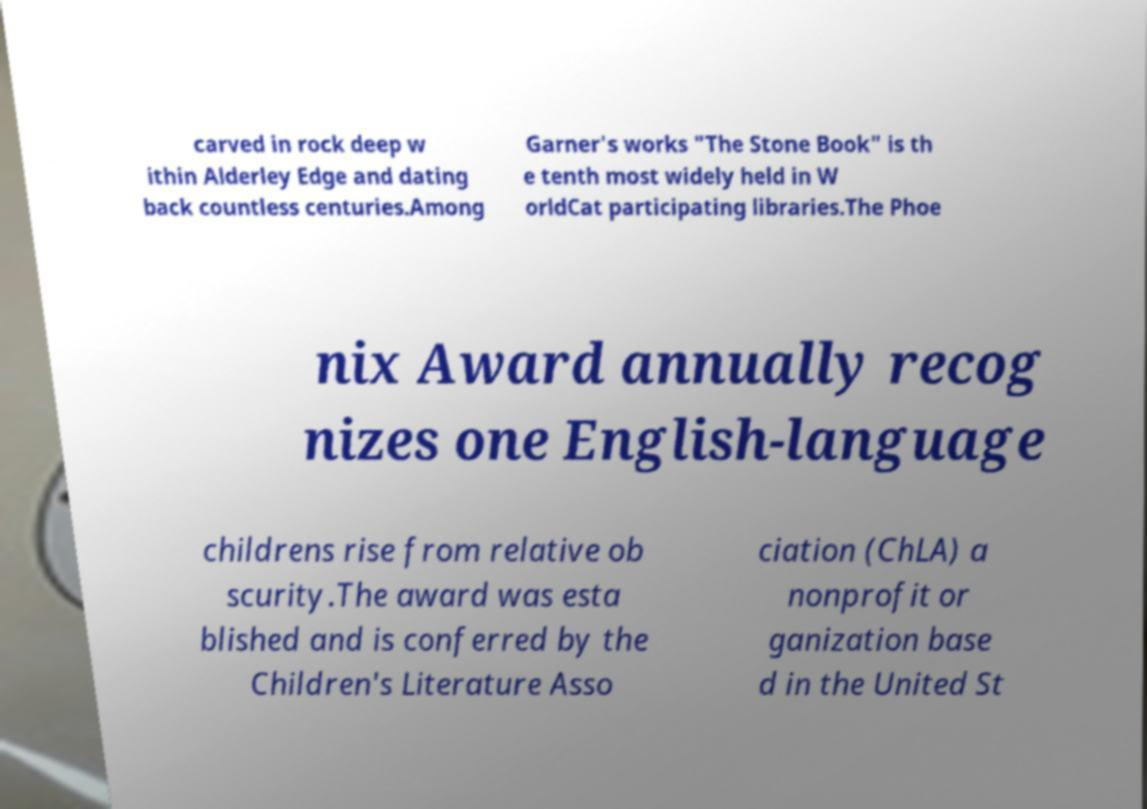I need the written content from this picture converted into text. Can you do that? carved in rock deep w ithin Alderley Edge and dating back countless centuries.Among Garner's works "The Stone Book" is th e tenth most widely held in W orldCat participating libraries.The Phoe nix Award annually recog nizes one English-language childrens rise from relative ob scurity.The award was esta blished and is conferred by the Children's Literature Asso ciation (ChLA) a nonprofit or ganization base d in the United St 